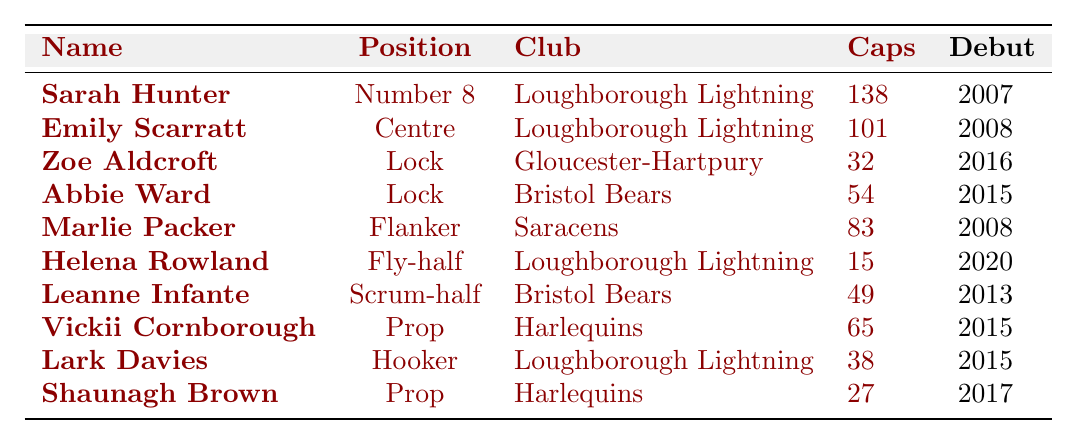What is the position of Sarah Hunter? Sarah Hunter's position is listed in the table under the 'Position' column. It states she plays as Number 8.
Answer: Number 8 How many caps does Emily Scarratt have? The number of caps is found in the table under Emily Scarratt’s entry in the 'Caps' column, which shows 101.
Answer: 101 Which player debuted in 2020? I can identify the debut year from the 'Debut' column, and Helena Rowland is the only player listed with a debut year of 2020.
Answer: Helena Rowland What club does Marlie Packer play for? The club affiliation is shown in the table, where Marlie Packer is associated with Saracens in the 'Club' column.
Answer: Saracens How many total caps do the players listed in the table have? To find the total caps, I sum the values in the 'Caps' column: 138 + 101 + 32 + 54 + 83 + 15 + 49 + 65 + 38 + 27 =  562.
Answer: 562 Who has the most caps? By reviewing the 'Caps' column, Sarah Hunter has the highest count with 138 caps.
Answer: Sarah Hunter Is Loughborough Lightning the club for the most players in the roster? I count the occurrences of each club in the table. Loughborough Lightning appears for three players, which is more than any other club.
Answer: Yes What is the average number of caps for players in this roster? To calculate the average, first sum the caps (562, as previously calculated) and divide by the number of players (10): 562 / 10 = 56.2.
Answer: 56.2 Which position has the least number of players represented? I analyze the 'Position' column: Scrum-half, Hooker, and Fly-half each have only one player listed, making these positions the least represented.
Answer: Scrum-half, Hooker, Fly-half Does any player share the same club as Marlie Packer? I check the club affiliation for Marlie Packer, which is Saracens. Looking at the table, there are no other players listed under Saracens.
Answer: No 